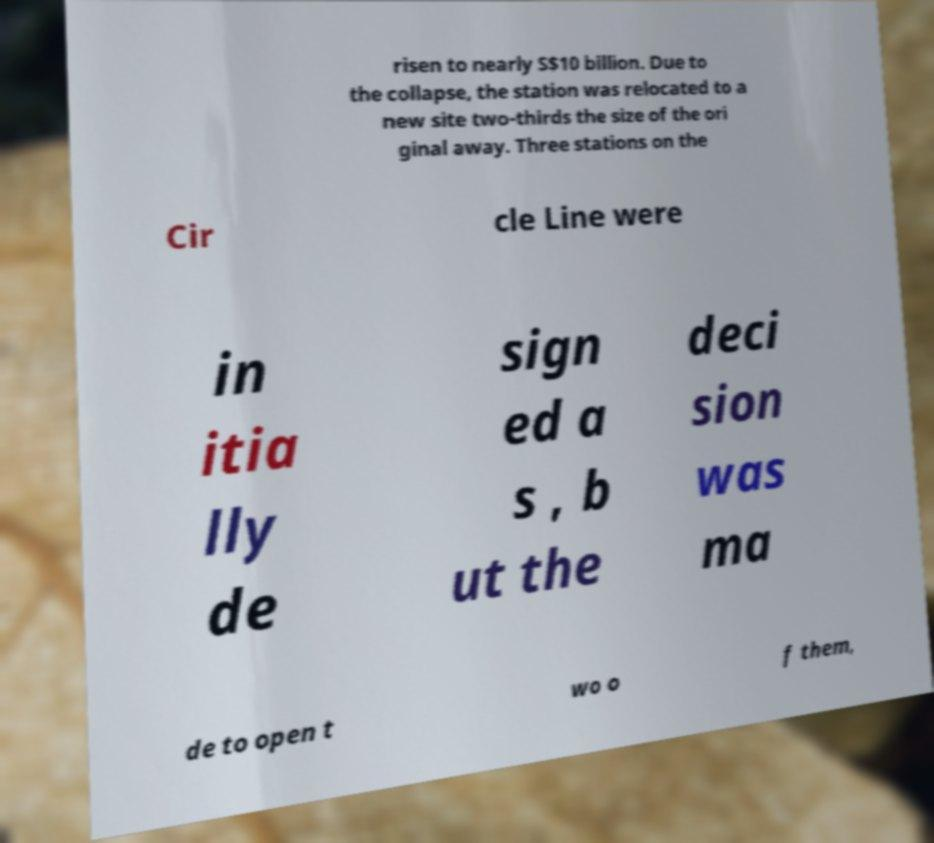Can you read and provide the text displayed in the image?This photo seems to have some interesting text. Can you extract and type it out for me? risen to nearly S$10 billion. Due to the collapse, the station was relocated to a new site two-thirds the size of the ori ginal away. Three stations on the Cir cle Line were in itia lly de sign ed a s , b ut the deci sion was ma de to open t wo o f them, 